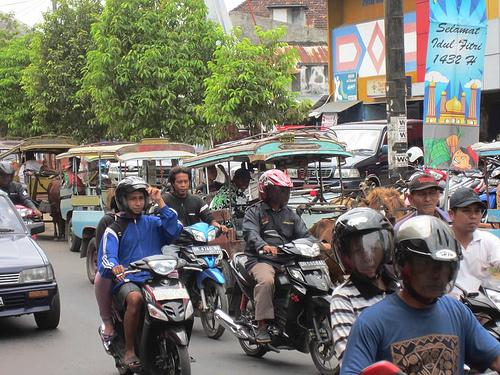What special feature can be observed on the blue shirt worn by a man in the image? The blue shirt has a tan and gold design. What is the color of the helmet that the man is wearing while riding the motorcycle? The helmet is black with a white stripe. Identify and describe the main mode of transportation in the congested street. The main mode of transportation is motorcycles, with many people riding them. Mention a type of outdoor advertisement present in the image. There is a large square blue and green banner hanging on a building. What type of footwear is a man wearing in the image? The man is wearing black flip flops. Are there any trees in the image? If yes, describe their characteristics. Yes, there are green trees on the side of the street which are full of leaves. Describe the vehicle that has front headlights, as seen in the image. The vehicle is a gray car. What is the color and pattern of the top worn by a man in khaki pants? The top is blue with black and white stripes. What specific accessory is wrongfully described as being worn by the man riding the motorcycle? The man is wrongfully described as wearing a baseball cap. Describe the condition of the roadway in the image. The roadway is dry and clear with a gray color. How many people are wearing helmets in the image? (a) 1 (b) 2 (c) 3 (d) 4 (b) 2 Describe the layout of the objects in the image as if it were a diagram. At the center, a man rides a motorcycle among a group of scooter riders on a congested street lined with green trees and buildings with banners. Can you read the text on the banner in the image? Not enough information to read the text on the banner. Point out the pink flowers on the green trees. No, it's not mentioned in the image. Explain how the objects in the image are related as if it were a flowchart. Starting point- congested street -> man riding a motorcycle -> green trees at the roadside -> people wearing helmets/ baseball caps -> advertising on buildings What is the man doing in the image? riding a motorcycle Describe the scene in a news reporter style. Breaking news: Traffic congestion observed in the city today, with numerous individuals traversing the bustling streets on motorcycles and scooters while donning helmets and riding gear. Describe the green top of the bus in detail. The green top of the bus is a rusty shade and is located amid the congestion on the street. Identify the activity being performed by the man on the motorcycle. The man is riding a motorcycle. Is there an event happening with a horse in the image? No, there is no horse in the image. Read the advertising hanging on the building. Not enough information to read the advertising. Detect any event happening in the image. There is a congested traffic event with people riding motorcycles and scooters. Describe the blue windbreaker with white stripes. The blue windbreaker has white stripes on it and covers the person's upper body. What is the man with curly hair doing? He is riding a motorcycle. Using elements from the image, craft a scene in which the man on the motorcycle has an interesting encounter with a scooter rider. As the man on the motorcycle navigated the bustling streets, he suddenly found himself locked in a friendly race with a daring scooter rider, both swiftly evading pedestrians and weaving through the verdant trees that lined their path. Create a story combining the elements in the image such as the man riding the motorcycle and the green trees on the side of the street. Once upon a time, in a bustling city, a man rode his motorcycle through the crowded streets, weaving through scooter riders and leafy green trees, determined to reach his destination in time. Describe the scene in a poetic style. Amidst the bustling street, motley riders adorned in helmets and caps weave through the verdant urban forest. Can you identify the man's emotions in the image with a baseball cap? Not enough information to determine the man's emotions. Does the scene depict a congested street with multiple people riding motorcycles? Yes List the colors of the jackets found in the image. blue, black, blue with white stripes 